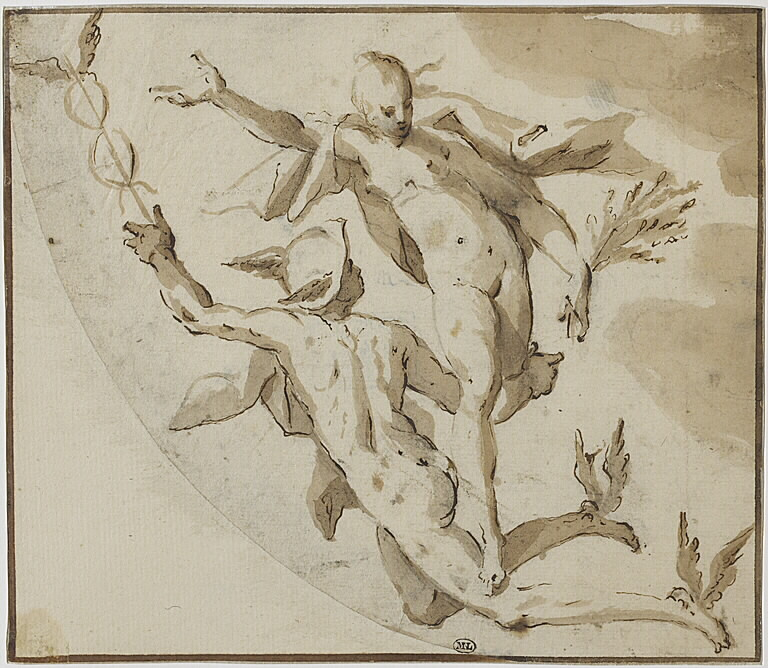Let's dream big! If this scene were part of a grand spectacle in an enchanted forest, what magical elements would you include? In an enchanted forest, this scene would come alive with magical elements. The male figure would have shimmering wings glistening with iridescent colors, catching the dappled sunlight streaming through the canopy. The female figure, adorned with delicate, ethereal garments, would emit a soft, glowing light, illuminating the surrounding foliage. Flitting around them, tiny sprites and fairies with luminescent trails would dance in the air, creating a mesmerizing display of light and movement. The forest itself would be alive with enchantment—trees whispering ancient secrets, flowers blooming in radiant hues, and a gentle, melodic breeze carrying the harmonious sounds of the forest. In this magical setting, the scene would be a celebration of nature, wonder, and the uniting power of otherworldly forces. 